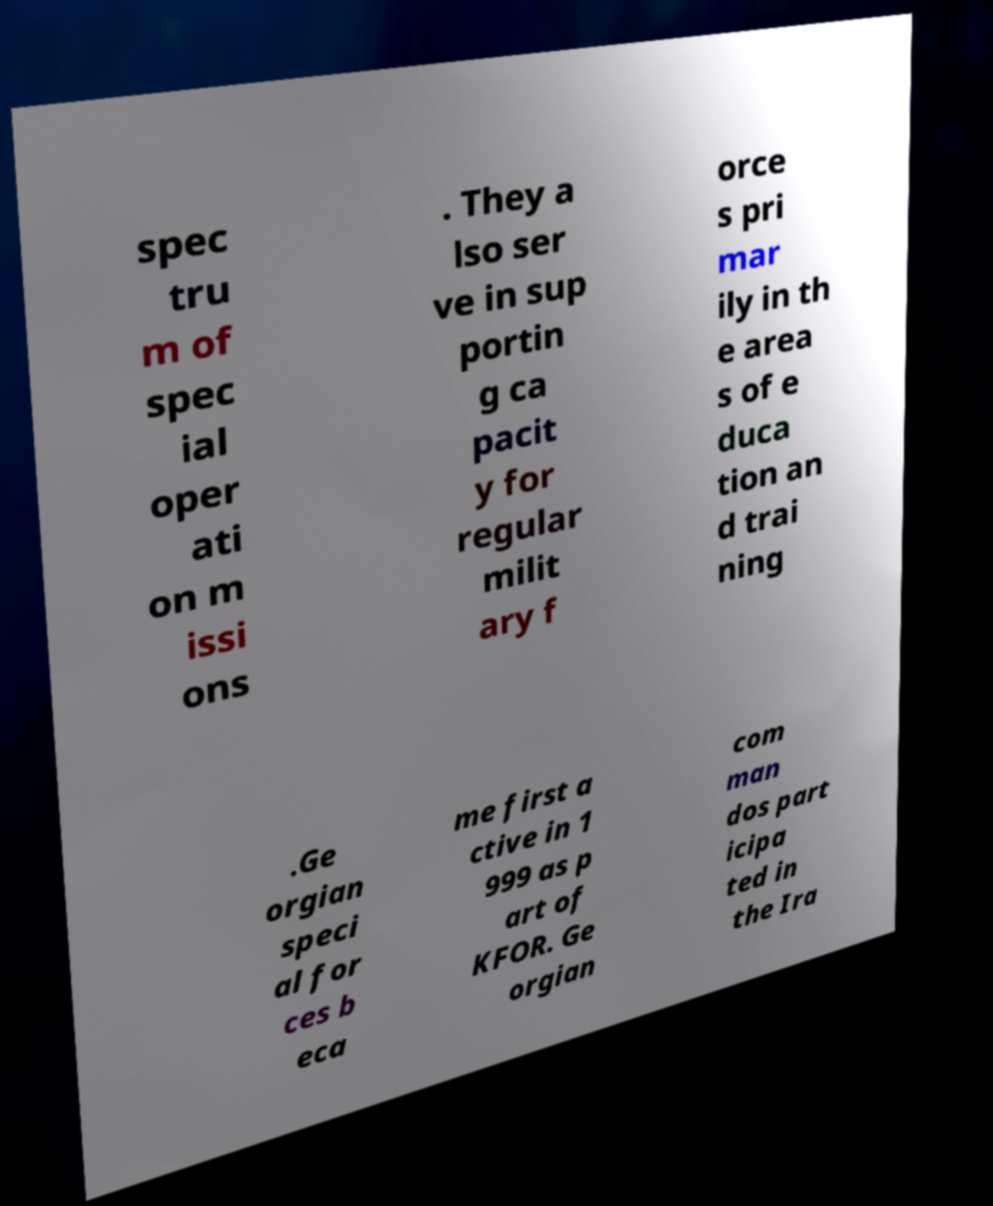Please identify and transcribe the text found in this image. spec tru m of spec ial oper ati on m issi ons . They a lso ser ve in sup portin g ca pacit y for regular milit ary f orce s pri mar ily in th e area s of e duca tion an d trai ning .Ge orgian speci al for ces b eca me first a ctive in 1 999 as p art of KFOR. Ge orgian com man dos part icipa ted in the Ira 